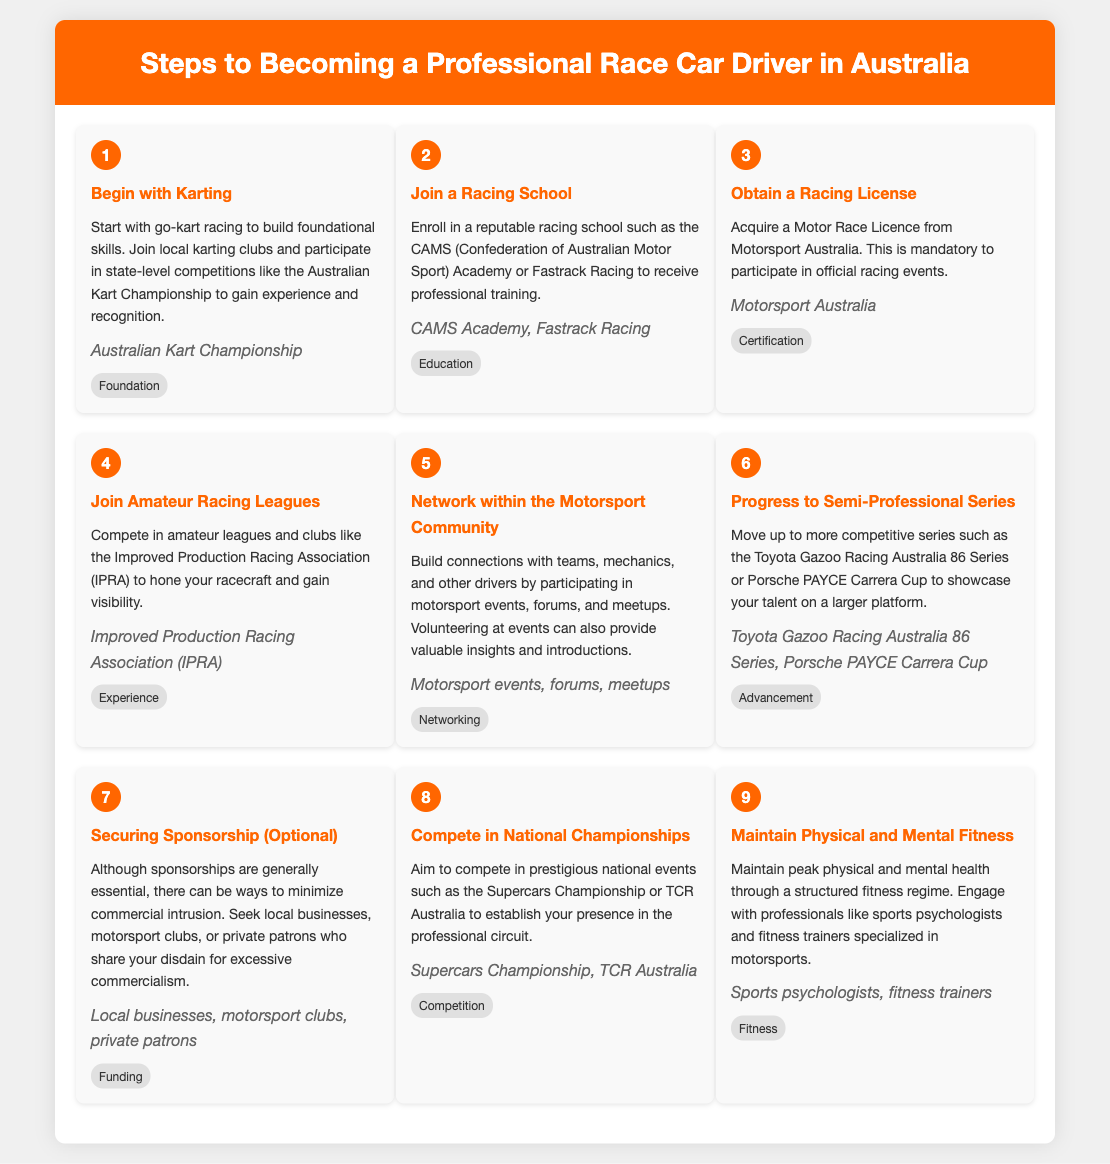What is the first step to becoming a professional race car driver in Australia? The first step listed in the infographic is to "Begin with Karting," where foundational skills are built through local competitions.
Answer: Begin with Karting Which organization offers a Motor Race Licence? The Motor Race Licence is issued by "Motorsport Australia," as stated in the document.
Answer: Motorsport Australia What is an optional step mentioned for aspiring drivers? The document mentions "Securing Sponsorship (Optional)" as a step, indicating a possible approach to funding.
Answer: Securing Sponsorship What series should drivers progress to after amateur leagues? The next level for drivers after amateur leagues is to move up to "Semi-Professional Series" such as the Toyota Gazoo Racing Australia 86 Series.
Answer: Semi-Professional Series Which national events are recommended for participants to compete in? The document suggests competing in prestigious events such as the "Supercars Championship or TCR Australia."
Answer: Supercars Championship, TCR Australia What aspect of training is highlighted in step nine? Step nine emphasizes the importance of "Maintain Physical and Mental Fitness" for aspiring race car drivers.
Answer: Maintain Physical and Mental Fitness How many total steps are outlined in the process? The infographic consists of nine steps in total towards becoming a professional race car driver.
Answer: Nine Where can one receive professional racing training according to the document? The document lists "CAMS Academy" and "Fastrack Racing" as reputable institutions for training.
Answer: CAMS Academy, Fastrack Racing What type of networking is suggested for becoming a professional driver? The suggested networking involves connecting with teams, mechanics, and other drivers through "motorsport events, forums, meetups."
Answer: Networking 